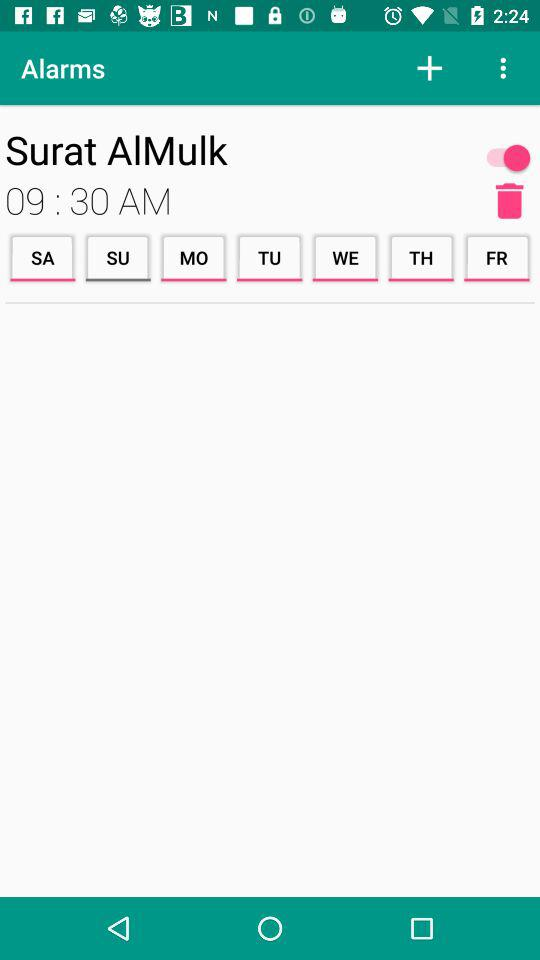What is the time set for the alarm? The set time is 9:30 AM. 